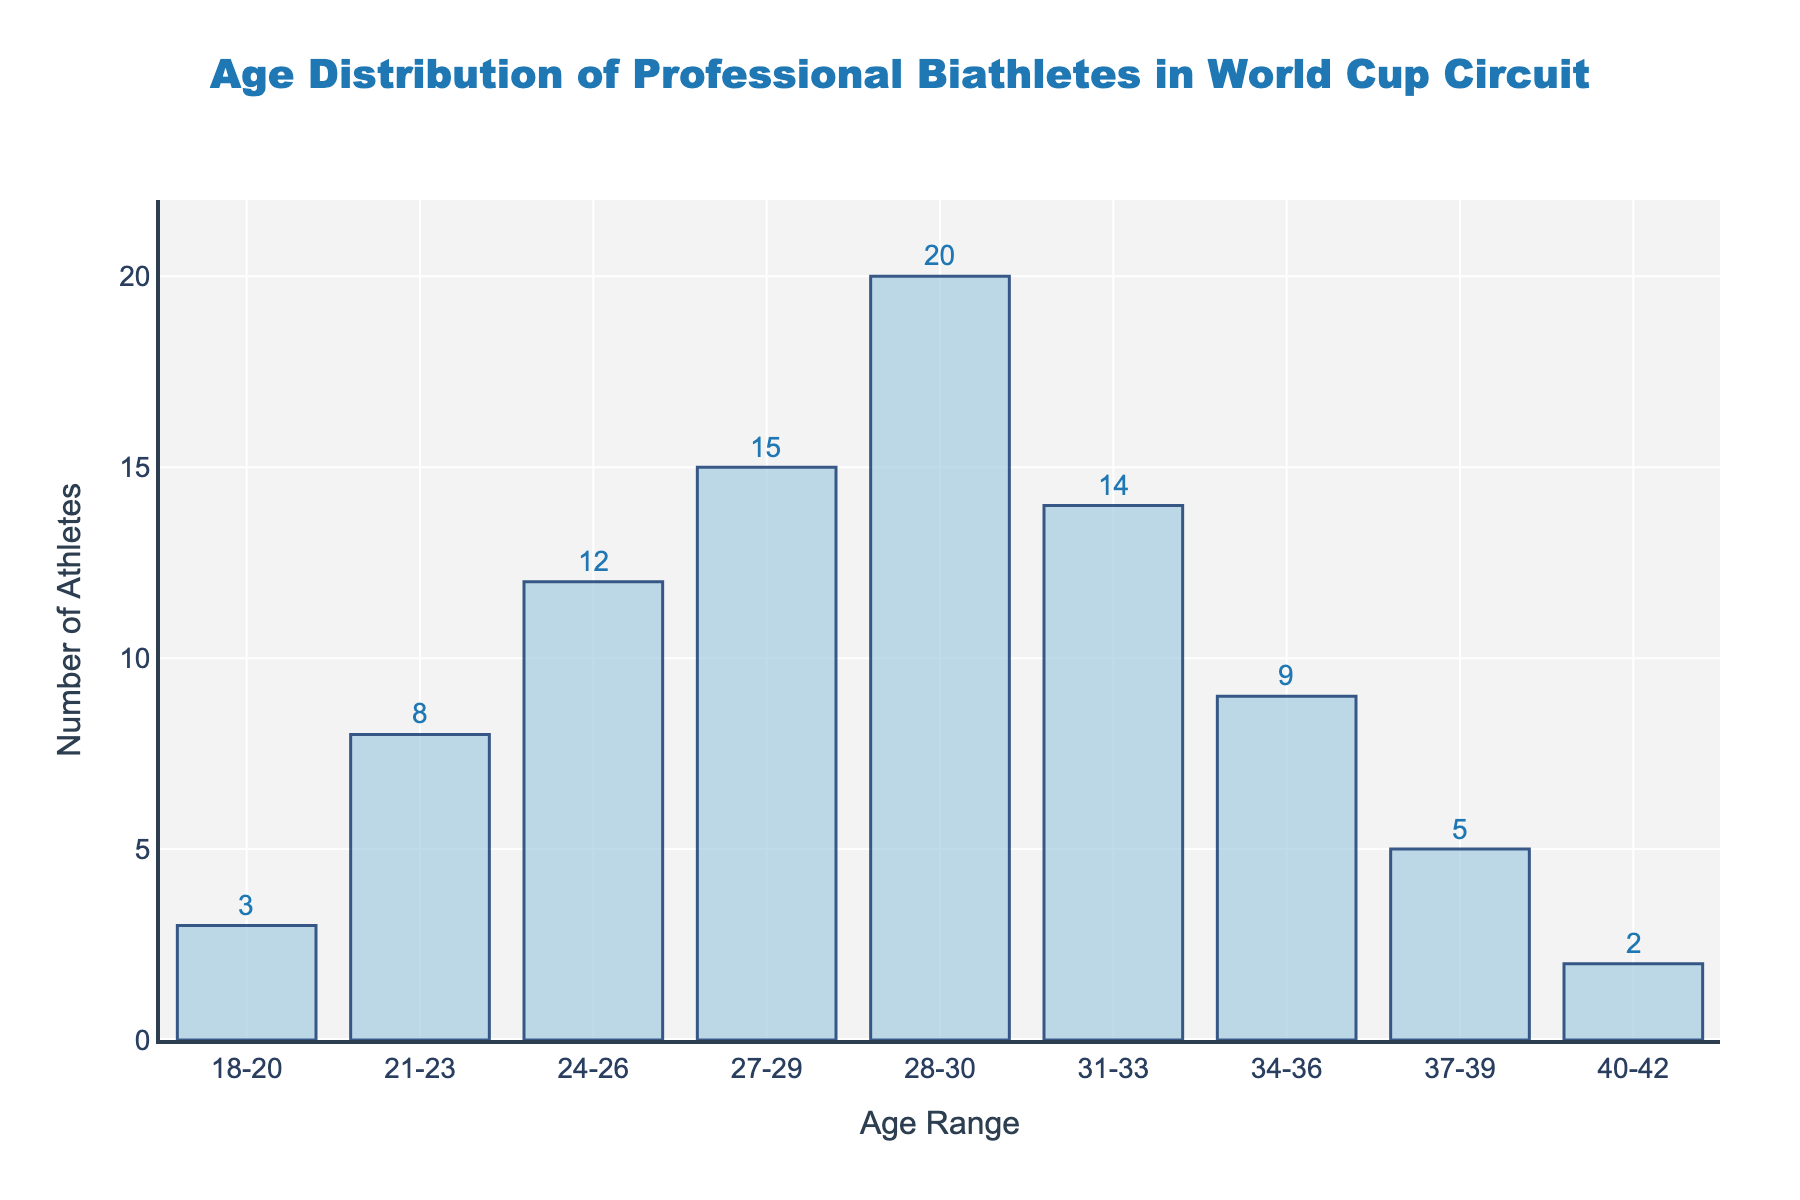What is the title of the histogram? The title is always displayed at the top of the histogram. In this case, it reads "Age Distribution of Professional Biathletes in World Cup Circuit."
Answer: Age Distribution of Professional Biathletes in World Cup Circuit What is the age range with the highest frequency of athletes? By examining the height of the bars, the tallest bar represents the age range of 28-30. This indicates the highest number of athletes.
Answer: 28-30 How many athletes are in the age range 24-26? Look at the specific bar corresponding to the age range 24-26. The number on top of that bar is 12.
Answer: 12 What is the total number of athletes aged between 18 and 23? Sum the frequencies of the bars for the age ranges 18-20 and 21-23. That is 3 + 8.
Answer: 11 How many more athletes are there in the age range 31-33 compared to 37-39? Look at the frequencies for each range and subtract the smaller value from the larger one: 14 (31-33) - 5 (37-39).
Answer: 9 Which age range has the fewest athletes? The shortest bar represents the fewest athletes, which is the age range 40-42, with a frequency of 2.
Answer: 40-42 What is the total number of athletes represented in the histogram? Sum all the frequencies: 3 + 8 + 12 + 15 + 20 + 14 + 9 + 5 + 2.
Answer: 88 How many age ranges have more than 10 athletes? Check the bars and see how many have a height greater than 10: 24-26, 27-29, 28-30, and 31-33. There are 4 such bars.
Answer: 4 What is the difference in the number of athletes between the age ranges 28-30 and 34-36? Subtract the frequency of the 34-36 age range from the 28-30 age range: 20 - 9.
Answer: 11 Is the distribution skewed towards younger or older ages? Compare the frequencies. Although there are significant athletes in later age ranges, the highest concentration seems to be around the mid to late 20s. The distribution is slightly skewed towards older athletes due to the higher frequencies in the age ranges 27-30 and 31-33.
Answer: Slightly towards older ages 